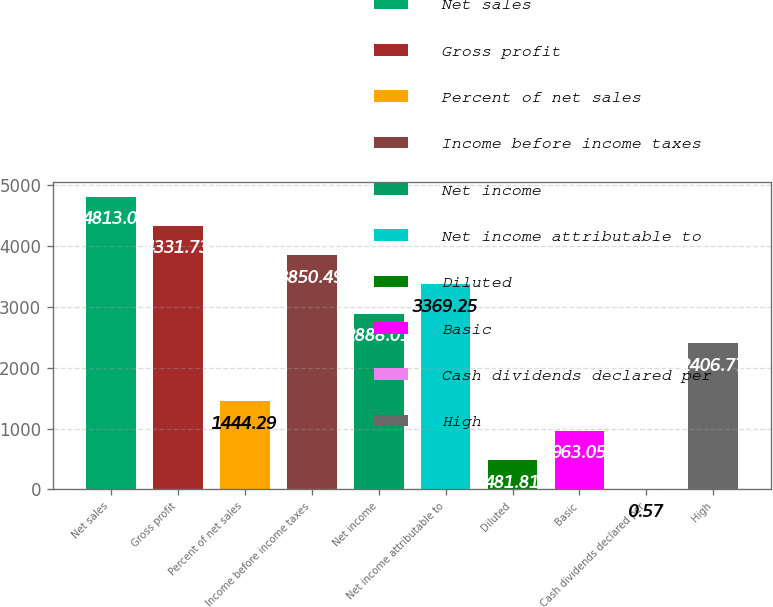<chart> <loc_0><loc_0><loc_500><loc_500><bar_chart><fcel>Net sales<fcel>Gross profit<fcel>Percent of net sales<fcel>Income before income taxes<fcel>Net income<fcel>Net income attributable to<fcel>Diluted<fcel>Basic<fcel>Cash dividends declared per<fcel>High<nl><fcel>4813<fcel>4331.73<fcel>1444.29<fcel>3850.49<fcel>2888.01<fcel>3369.25<fcel>481.81<fcel>963.05<fcel>0.57<fcel>2406.77<nl></chart> 